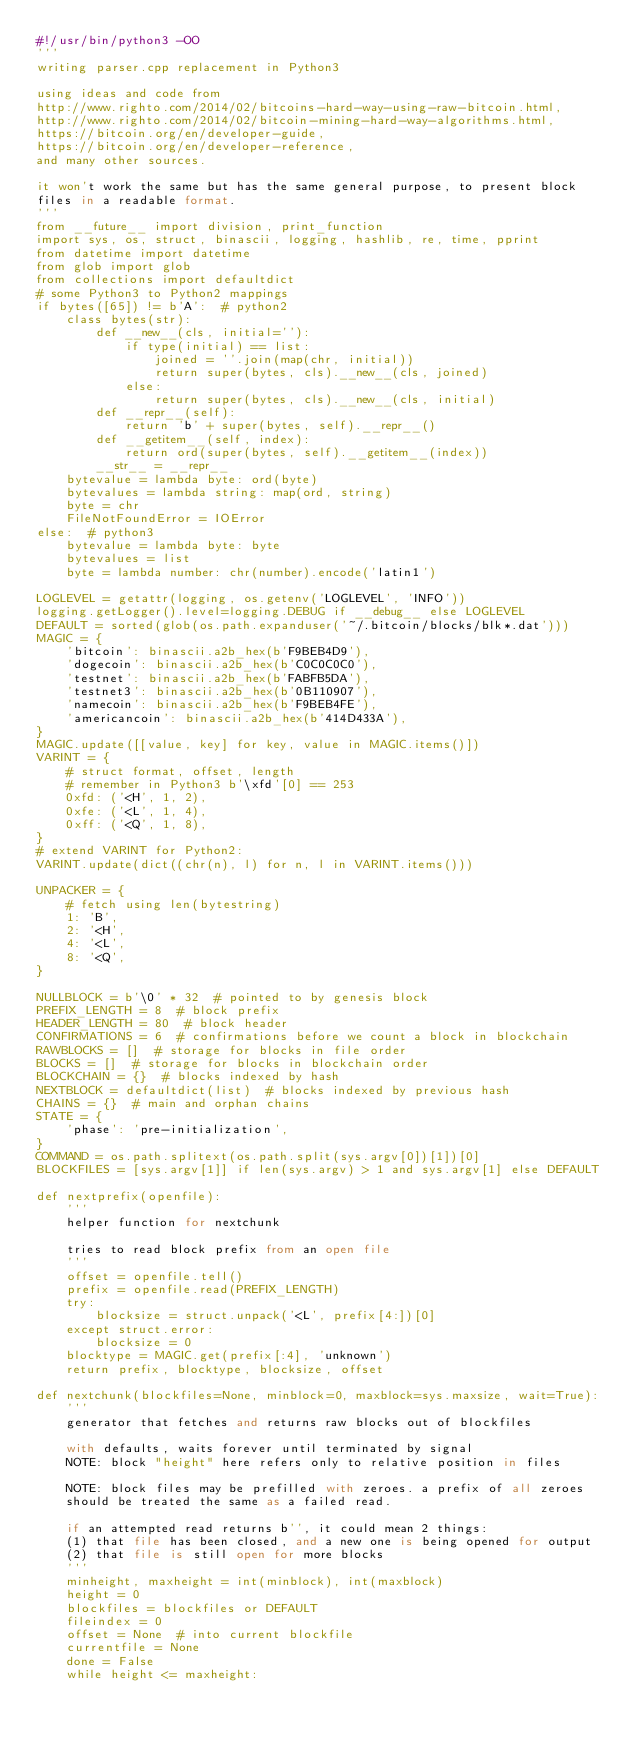Convert code to text. <code><loc_0><loc_0><loc_500><loc_500><_Python_>#!/usr/bin/python3 -OO
'''
writing parser.cpp replacement in Python3

using ideas and code from
http://www.righto.com/2014/02/bitcoins-hard-way-using-raw-bitcoin.html,
http://www.righto.com/2014/02/bitcoin-mining-hard-way-algorithms.html,
https://bitcoin.org/en/developer-guide,
https://bitcoin.org/en/developer-reference,
and many other sources.

it won't work the same but has the same general purpose, to present block
files in a readable format.
'''
from __future__ import division, print_function
import sys, os, struct, binascii, logging, hashlib, re, time, pprint
from datetime import datetime
from glob import glob
from collections import defaultdict
# some Python3 to Python2 mappings
if bytes([65]) != b'A':  # python2
    class bytes(str):
        def __new__(cls, initial=''):
            if type(initial) == list:
                joined = ''.join(map(chr, initial))
                return super(bytes, cls).__new__(cls, joined)
            else:
                return super(bytes, cls).__new__(cls, initial)
        def __repr__(self):
            return 'b' + super(bytes, self).__repr__()
        def __getitem__(self, index):
            return ord(super(bytes, self).__getitem__(index))
        __str__ = __repr__
    bytevalue = lambda byte: ord(byte)
    bytevalues = lambda string: map(ord, string)
    byte = chr
    FileNotFoundError = IOError
else:  # python3
    bytevalue = lambda byte: byte
    bytevalues = list
    byte = lambda number: chr(number).encode('latin1')

LOGLEVEL = getattr(logging, os.getenv('LOGLEVEL', 'INFO'))
logging.getLogger().level=logging.DEBUG if __debug__ else LOGLEVEL
DEFAULT = sorted(glob(os.path.expanduser('~/.bitcoin/blocks/blk*.dat')))
MAGIC = {
    'bitcoin': binascii.a2b_hex(b'F9BEB4D9'),
    'dogecoin': binascii.a2b_hex(b'C0C0C0C0'),
    'testnet': binascii.a2b_hex(b'FABFB5DA'),
    'testnet3': binascii.a2b_hex(b'0B110907'),
    'namecoin': binascii.a2b_hex(b'F9BEB4FE'),
    'americancoin': binascii.a2b_hex(b'414D433A'),
}
MAGIC.update([[value, key] for key, value in MAGIC.items()])
VARINT = {
    # struct format, offset, length
    # remember in Python3 b'\xfd'[0] == 253
    0xfd: ('<H', 1, 2),
    0xfe: ('<L', 1, 4),
    0xff: ('<Q', 1, 8),
}
# extend VARINT for Python2:
VARINT.update(dict((chr(n), l) for n, l in VARINT.items()))

UNPACKER = {
    # fetch using len(bytestring)
    1: 'B',
    2: '<H',
    4: '<L',
    8: '<Q',
}

NULLBLOCK = b'\0' * 32  # pointed to by genesis block
PREFIX_LENGTH = 8  # block prefix
HEADER_LENGTH = 80  # block header
CONFIRMATIONS = 6  # confirmations before we count a block in blockchain
RAWBLOCKS = []  # storage for blocks in file order
BLOCKS = []  # storage for blocks in blockchain order
BLOCKCHAIN = {}  # blocks indexed by hash
NEXTBLOCK = defaultdict(list)  # blocks indexed by previous hash
CHAINS = {}  # main and orphan chains
STATE = {
    'phase': 'pre-initialization',
}
COMMAND = os.path.splitext(os.path.split(sys.argv[0])[1])[0]
BLOCKFILES = [sys.argv[1]] if len(sys.argv) > 1 and sys.argv[1] else DEFAULT

def nextprefix(openfile):
    '''
    helper function for nextchunk

    tries to read block prefix from an open file
    '''
    offset = openfile.tell()
    prefix = openfile.read(PREFIX_LENGTH)
    try:
        blocksize = struct.unpack('<L', prefix[4:])[0]
    except struct.error:
        blocksize = 0
    blocktype = MAGIC.get(prefix[:4], 'unknown')
    return prefix, blocktype, blocksize, offset

def nextchunk(blockfiles=None, minblock=0, maxblock=sys.maxsize, wait=True):
    '''
    generator that fetches and returns raw blocks out of blockfiles

    with defaults, waits forever until terminated by signal
    NOTE: block "height" here refers only to relative position in files

    NOTE: block files may be prefilled with zeroes. a prefix of all zeroes
    should be treated the same as a failed read.

    if an attempted read returns b'', it could mean 2 things:
    (1) that file has been closed, and a new one is being opened for output
    (2) that file is still open for more blocks
    '''
    minheight, maxheight = int(minblock), int(maxblock)
    height = 0
    blockfiles = blockfiles or DEFAULT
    fileindex = 0
    offset = None  # into current blockfile
    currentfile = None
    done = False
    while height <= maxheight:</code> 